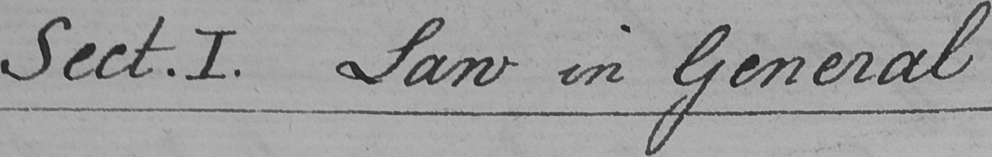Please transcribe the handwritten text in this image. Sect . I . Law in General 